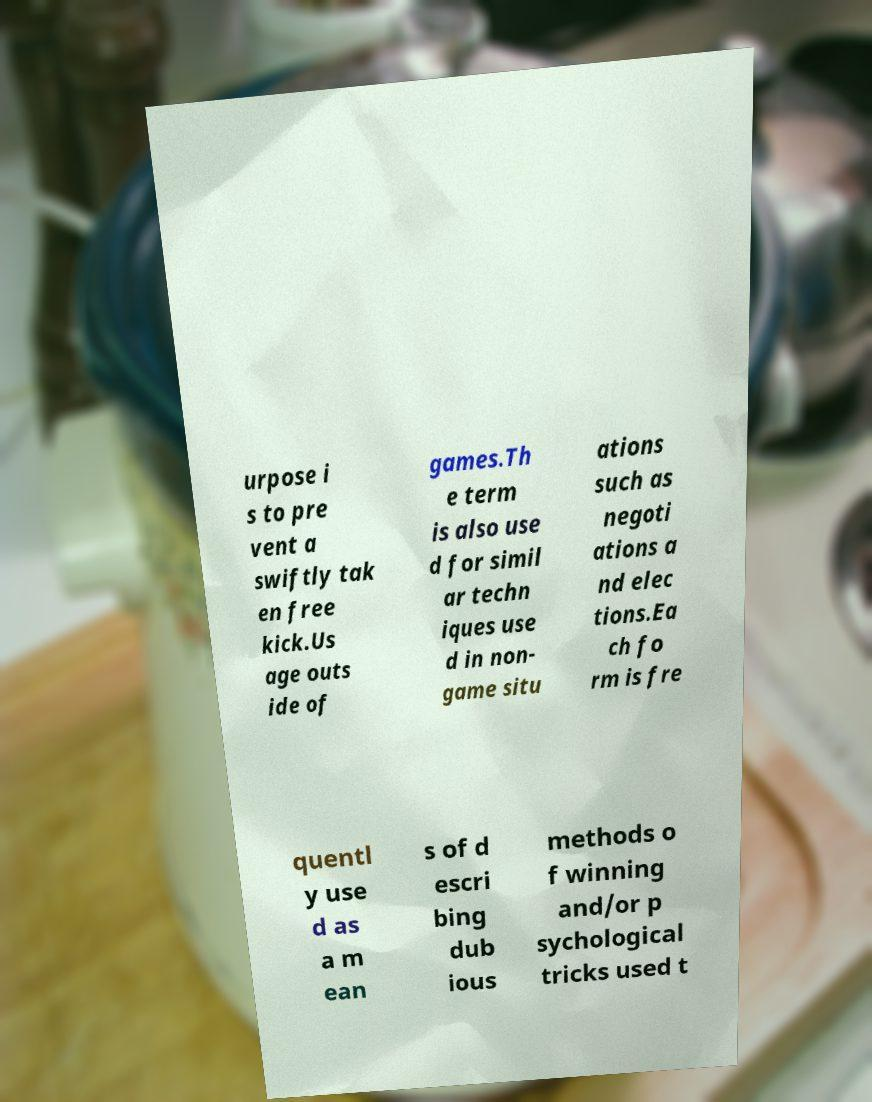What messages or text are displayed in this image? I need them in a readable, typed format. urpose i s to pre vent a swiftly tak en free kick.Us age outs ide of games.Th e term is also use d for simil ar techn iques use d in non- game situ ations such as negoti ations a nd elec tions.Ea ch fo rm is fre quentl y use d as a m ean s of d escri bing dub ious methods o f winning and/or p sychological tricks used t 